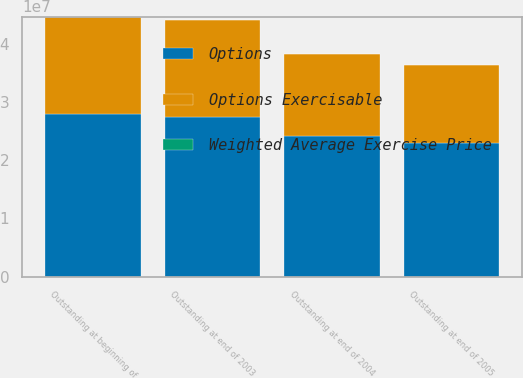<chart> <loc_0><loc_0><loc_500><loc_500><stacked_bar_chart><ecel><fcel>Outstanding at beginning of<fcel>Outstanding at end of 2003<fcel>Outstanding at end of 2004<fcel>Outstanding at end of 2005<nl><fcel>Options<fcel>2.79439e+07<fcel>2.74258e+07<fcel>2.41304e+07<fcel>2.29484e+07<nl><fcel>Weighted Average Exercise Price<fcel>26.25<fcel>29.98<fcel>36.65<fcel>42.84<nl><fcel>Options Exercisable<fcel>1.67596e+07<fcel>1.6608e+07<fcel>1.41619e+07<fcel>1.34895e+07<nl></chart> 